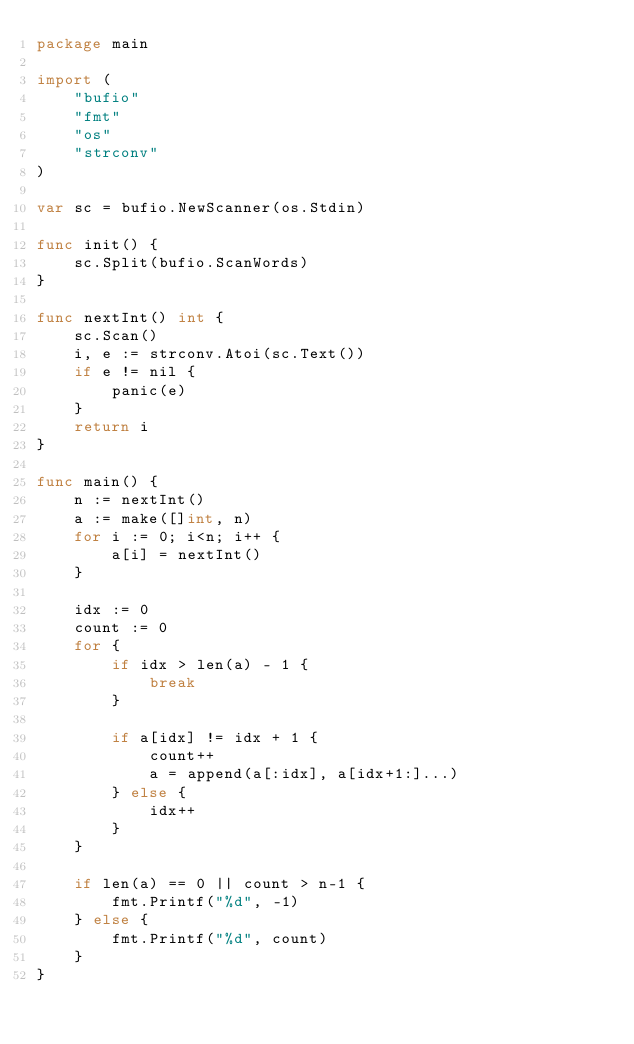Convert code to text. <code><loc_0><loc_0><loc_500><loc_500><_Go_>package main

import (
	"bufio"
	"fmt"
	"os"
	"strconv"
)

var sc = bufio.NewScanner(os.Stdin)

func init() {
	sc.Split(bufio.ScanWords)
}

func nextInt() int {
	sc.Scan()
	i, e := strconv.Atoi(sc.Text())
	if e != nil {
		panic(e)
	}
	return i
}

func main() {
	n := nextInt()
	a := make([]int, n)
	for i := 0; i<n; i++ {
		a[i] = nextInt()
	}

	idx := 0
	count := 0
	for {
		if idx > len(a) - 1 {
			break
		}

		if a[idx] != idx + 1 {
			count++
			a = append(a[:idx], a[idx+1:]...)
		} else {
			idx++
		}
	}

	if len(a) == 0 || count > n-1 {
		fmt.Printf("%d", -1)
	} else {
		fmt.Printf("%d", count)
	}
}
</code> 